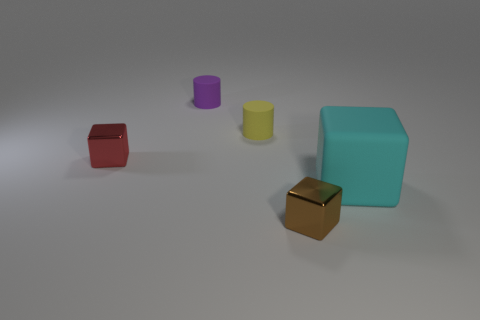Add 3 cyan rubber blocks. How many objects exist? 8 Subtract all cylinders. How many objects are left? 3 Add 5 purple objects. How many purple objects are left? 6 Add 3 cyan objects. How many cyan objects exist? 4 Subtract 0 brown cylinders. How many objects are left? 5 Subtract all cyan rubber objects. Subtract all small brown cubes. How many objects are left? 3 